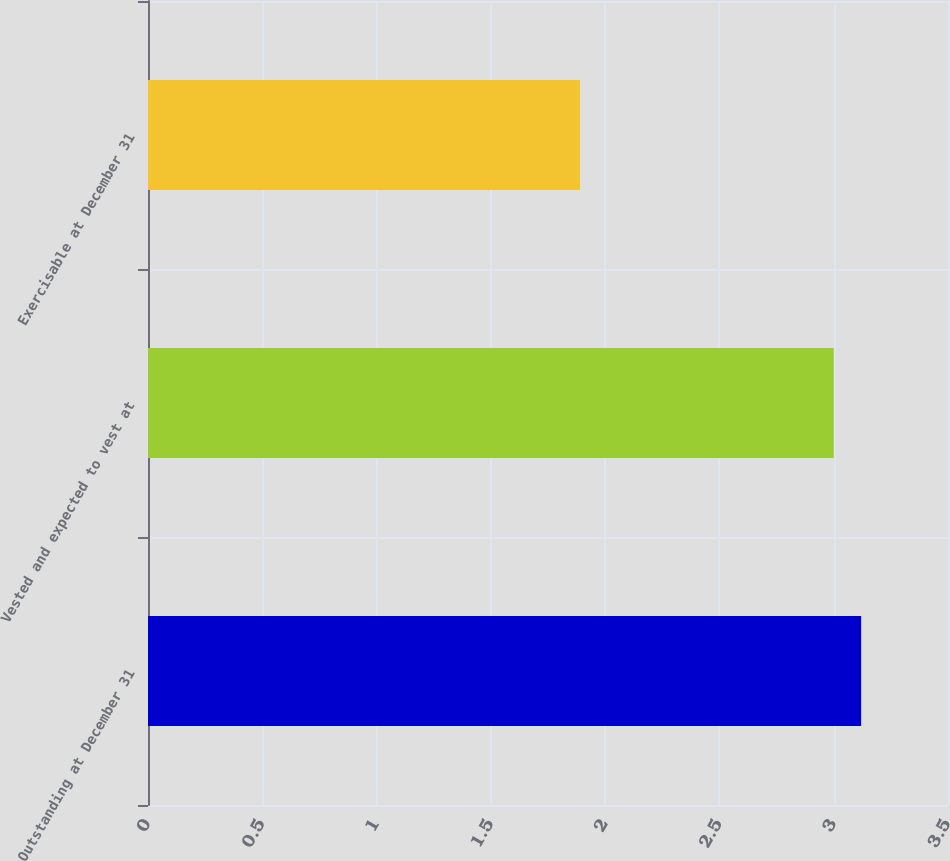<chart> <loc_0><loc_0><loc_500><loc_500><bar_chart><fcel>Outstanding at December 31<fcel>Vested and expected to vest at<fcel>Exercisable at December 31<nl><fcel>3.12<fcel>3<fcel>1.89<nl></chart> 